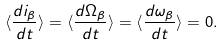Convert formula to latex. <formula><loc_0><loc_0><loc_500><loc_500>\langle \frac { d i _ { \beta } } { d t } \rangle = \langle \frac { d \Omega _ { \beta } } { d t } \rangle = \langle \frac { d \omega _ { \beta } } { d t } \rangle = 0 .</formula> 